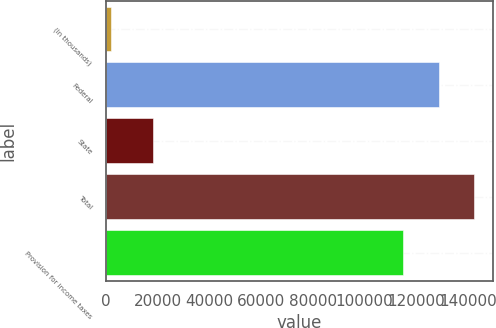Convert chart to OTSL. <chart><loc_0><loc_0><loc_500><loc_500><bar_chart><fcel>(In thousands)<fcel>Federal<fcel>State<fcel>Total<fcel>Provision for income taxes<nl><fcel>2008<fcel>128788<fcel>18175<fcel>142532<fcel>115044<nl></chart> 